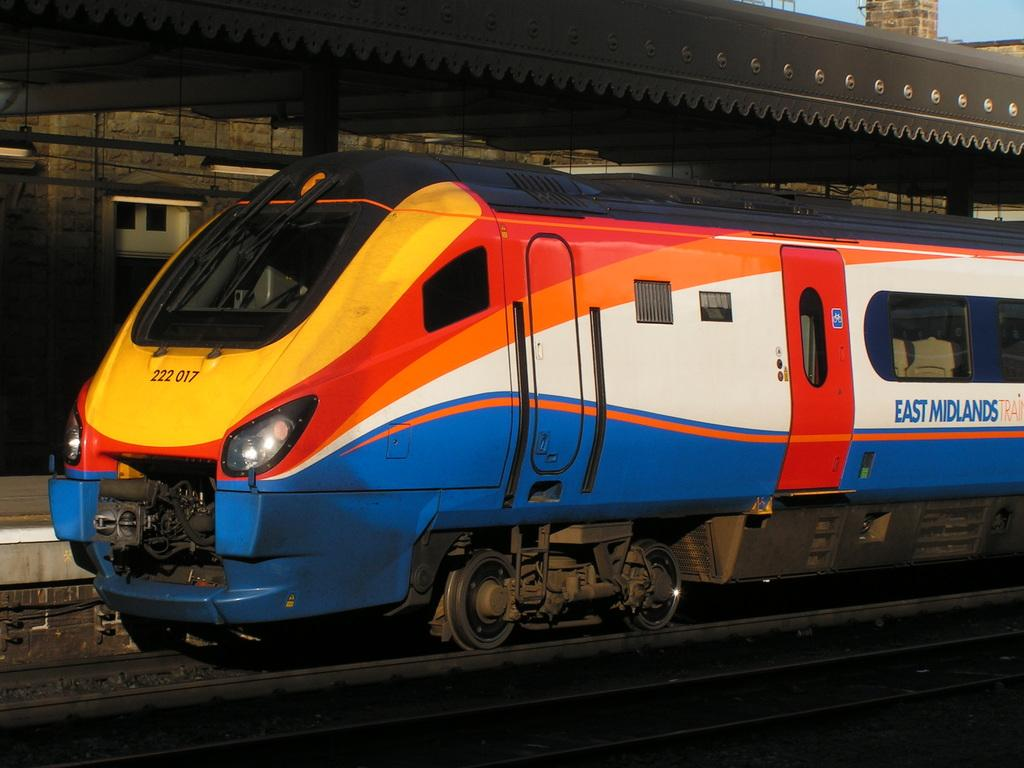What is the main subject of the image? The main subject of the image is a train. What is the train situated on in the image? The train is on tracks in the image. What structure is present near the train? There is a platform in the image. What type of roof does the platform have? The platform has an iron roof. How is the train positioned in relation to the platform? The train is beside the platform in the image. Can you see a fireman putting out a fire with his mouth in the image? There is no fireman or fire present in the image. What type of bird can be seen flying over the train in the image? There are no birds visible in the image. 